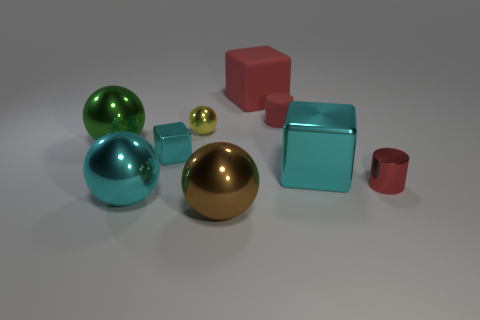How many cyan objects have the same size as the red shiny thing?
Ensure brevity in your answer.  1. Is the number of tiny things in front of the small red metal cylinder less than the number of tiny cyan cubes behind the large cyan shiny sphere?
Your answer should be compact. Yes. Is there another object that has the same shape as the tiny rubber object?
Make the answer very short. Yes. Is the tiny yellow object the same shape as the small cyan metal thing?
Provide a succinct answer. No. What number of large objects are either gray rubber balls or brown metallic balls?
Your answer should be compact. 1. Is the number of cyan shiny blocks greater than the number of large matte objects?
Make the answer very short. Yes. What is the size of the block that is made of the same material as the small cyan object?
Make the answer very short. Large. Is the size of the cylinder behind the green metallic thing the same as the yellow ball that is behind the cyan metallic ball?
Offer a very short reply. Yes. How many things are big cubes that are right of the tiny rubber thing or tiny gray objects?
Your answer should be very brief. 1. Are there fewer spheres than tiny red shiny cylinders?
Make the answer very short. No. 